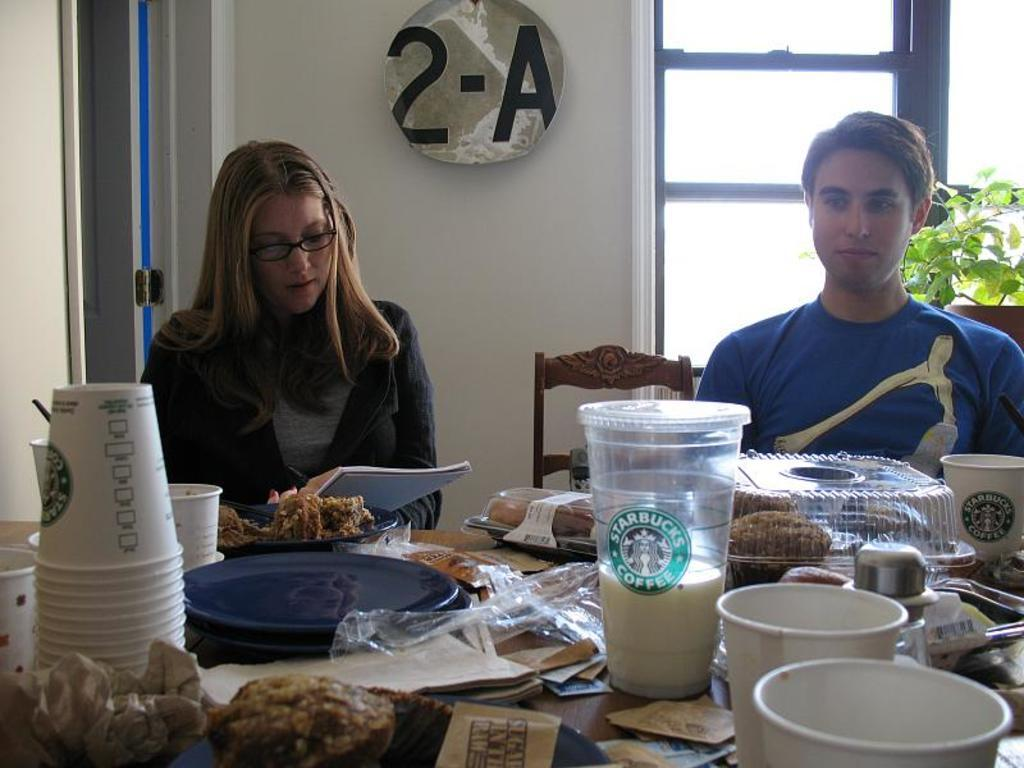What are the people in the image doing? People are sitting on chairs in the image. What can be seen on the table in the image? There is a glass, a cup, food, and a plate on the table in the image. What is visible in the background of the image? There is a window, a plant, and a wall in the background of the image. Where is the kettle located in the image? There is no kettle present in the image. What part of the plant is visible in the image? The image does not show a specific part of the plant; it only shows the plant as a whole. 